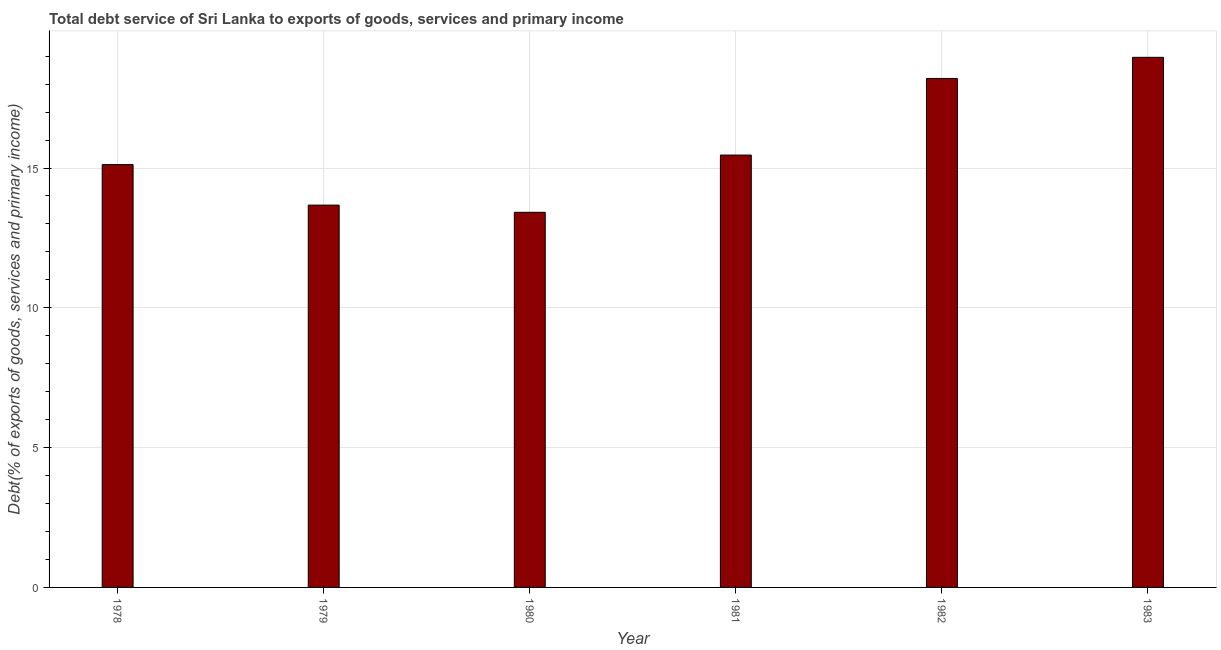What is the title of the graph?
Your answer should be compact. Total debt service of Sri Lanka to exports of goods, services and primary income. What is the label or title of the Y-axis?
Offer a very short reply. Debt(% of exports of goods, services and primary income). What is the total debt service in 1981?
Ensure brevity in your answer.  15.46. Across all years, what is the maximum total debt service?
Make the answer very short. 18.96. Across all years, what is the minimum total debt service?
Give a very brief answer. 13.42. In which year was the total debt service maximum?
Provide a short and direct response. 1983. In which year was the total debt service minimum?
Your answer should be very brief. 1980. What is the sum of the total debt service?
Provide a succinct answer. 94.84. What is the difference between the total debt service in 1980 and 1981?
Your response must be concise. -2.05. What is the average total debt service per year?
Provide a succinct answer. 15.81. What is the median total debt service?
Your answer should be compact. 15.29. In how many years, is the total debt service greater than 13 %?
Make the answer very short. 6. What is the ratio of the total debt service in 1981 to that in 1982?
Offer a very short reply. 0.85. Is the difference between the total debt service in 1978 and 1982 greater than the difference between any two years?
Your answer should be very brief. No. What is the difference between the highest and the second highest total debt service?
Your response must be concise. 0.76. What is the difference between the highest and the lowest total debt service?
Your response must be concise. 5.54. How many years are there in the graph?
Keep it short and to the point. 6. Are the values on the major ticks of Y-axis written in scientific E-notation?
Keep it short and to the point. No. What is the Debt(% of exports of goods, services and primary income) of 1978?
Offer a terse response. 15.12. What is the Debt(% of exports of goods, services and primary income) of 1979?
Your answer should be very brief. 13.67. What is the Debt(% of exports of goods, services and primary income) of 1980?
Offer a very short reply. 13.42. What is the Debt(% of exports of goods, services and primary income) in 1981?
Keep it short and to the point. 15.46. What is the Debt(% of exports of goods, services and primary income) of 1982?
Ensure brevity in your answer.  18.2. What is the Debt(% of exports of goods, services and primary income) of 1983?
Keep it short and to the point. 18.96. What is the difference between the Debt(% of exports of goods, services and primary income) in 1978 and 1979?
Your response must be concise. 1.45. What is the difference between the Debt(% of exports of goods, services and primary income) in 1978 and 1980?
Offer a terse response. 1.71. What is the difference between the Debt(% of exports of goods, services and primary income) in 1978 and 1981?
Give a very brief answer. -0.34. What is the difference between the Debt(% of exports of goods, services and primary income) in 1978 and 1982?
Make the answer very short. -3.08. What is the difference between the Debt(% of exports of goods, services and primary income) in 1978 and 1983?
Provide a succinct answer. -3.84. What is the difference between the Debt(% of exports of goods, services and primary income) in 1979 and 1980?
Make the answer very short. 0.26. What is the difference between the Debt(% of exports of goods, services and primary income) in 1979 and 1981?
Your answer should be compact. -1.79. What is the difference between the Debt(% of exports of goods, services and primary income) in 1979 and 1982?
Make the answer very short. -4.53. What is the difference between the Debt(% of exports of goods, services and primary income) in 1979 and 1983?
Give a very brief answer. -5.29. What is the difference between the Debt(% of exports of goods, services and primary income) in 1980 and 1981?
Your answer should be compact. -2.05. What is the difference between the Debt(% of exports of goods, services and primary income) in 1980 and 1982?
Your answer should be compact. -4.79. What is the difference between the Debt(% of exports of goods, services and primary income) in 1980 and 1983?
Provide a short and direct response. -5.54. What is the difference between the Debt(% of exports of goods, services and primary income) in 1981 and 1982?
Ensure brevity in your answer.  -2.74. What is the difference between the Debt(% of exports of goods, services and primary income) in 1981 and 1983?
Keep it short and to the point. -3.5. What is the difference between the Debt(% of exports of goods, services and primary income) in 1982 and 1983?
Provide a succinct answer. -0.75. What is the ratio of the Debt(% of exports of goods, services and primary income) in 1978 to that in 1979?
Offer a very short reply. 1.11. What is the ratio of the Debt(% of exports of goods, services and primary income) in 1978 to that in 1980?
Your answer should be compact. 1.13. What is the ratio of the Debt(% of exports of goods, services and primary income) in 1978 to that in 1982?
Keep it short and to the point. 0.83. What is the ratio of the Debt(% of exports of goods, services and primary income) in 1978 to that in 1983?
Your answer should be very brief. 0.8. What is the ratio of the Debt(% of exports of goods, services and primary income) in 1979 to that in 1980?
Your answer should be compact. 1.02. What is the ratio of the Debt(% of exports of goods, services and primary income) in 1979 to that in 1981?
Keep it short and to the point. 0.88. What is the ratio of the Debt(% of exports of goods, services and primary income) in 1979 to that in 1982?
Provide a short and direct response. 0.75. What is the ratio of the Debt(% of exports of goods, services and primary income) in 1979 to that in 1983?
Keep it short and to the point. 0.72. What is the ratio of the Debt(% of exports of goods, services and primary income) in 1980 to that in 1981?
Ensure brevity in your answer.  0.87. What is the ratio of the Debt(% of exports of goods, services and primary income) in 1980 to that in 1982?
Offer a terse response. 0.74. What is the ratio of the Debt(% of exports of goods, services and primary income) in 1980 to that in 1983?
Make the answer very short. 0.71. What is the ratio of the Debt(% of exports of goods, services and primary income) in 1981 to that in 1982?
Give a very brief answer. 0.85. What is the ratio of the Debt(% of exports of goods, services and primary income) in 1981 to that in 1983?
Make the answer very short. 0.82. What is the ratio of the Debt(% of exports of goods, services and primary income) in 1982 to that in 1983?
Keep it short and to the point. 0.96. 